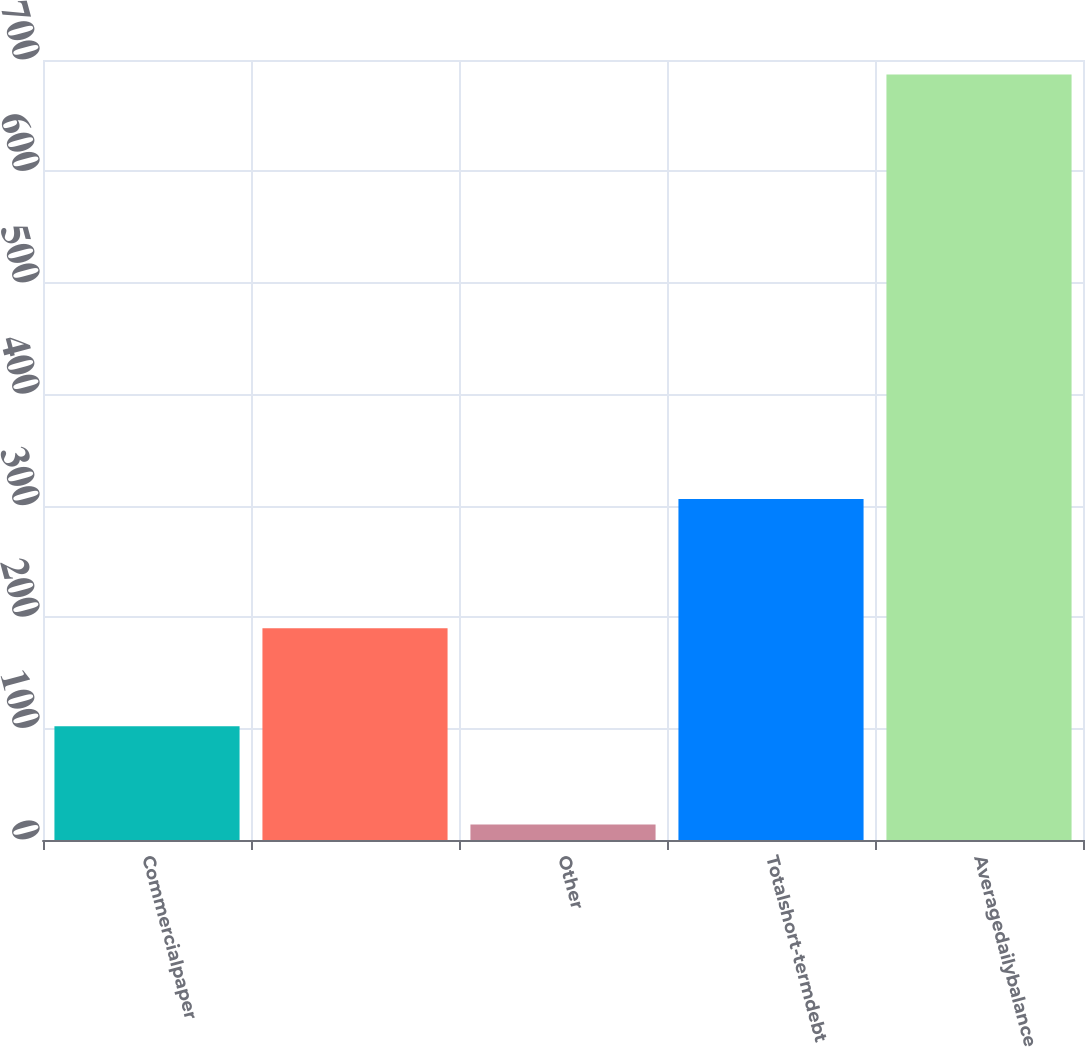<chart> <loc_0><loc_0><loc_500><loc_500><bar_chart><fcel>Commercialpaper<fcel>Unnamed: 1<fcel>Other<fcel>Totalshort-termdebt<fcel>Averagedailybalance<nl><fcel>102<fcel>190<fcel>14<fcel>306<fcel>687<nl></chart> 